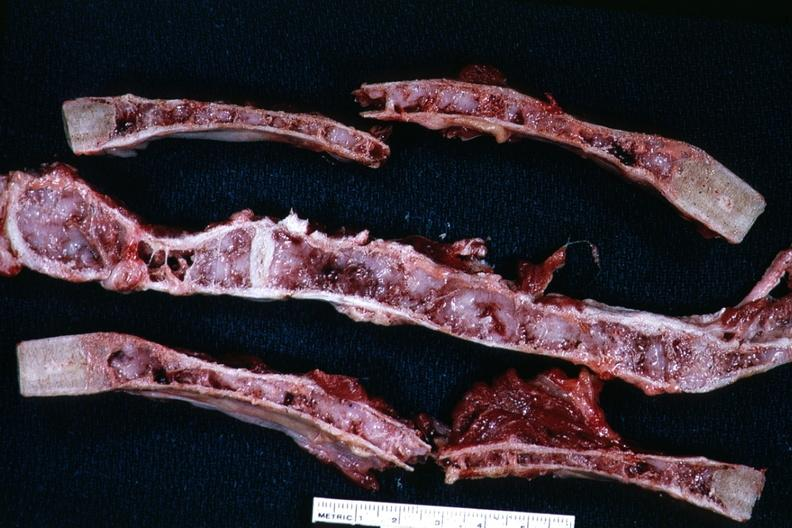what is present?
Answer the question using a single word or phrase. Thorax 